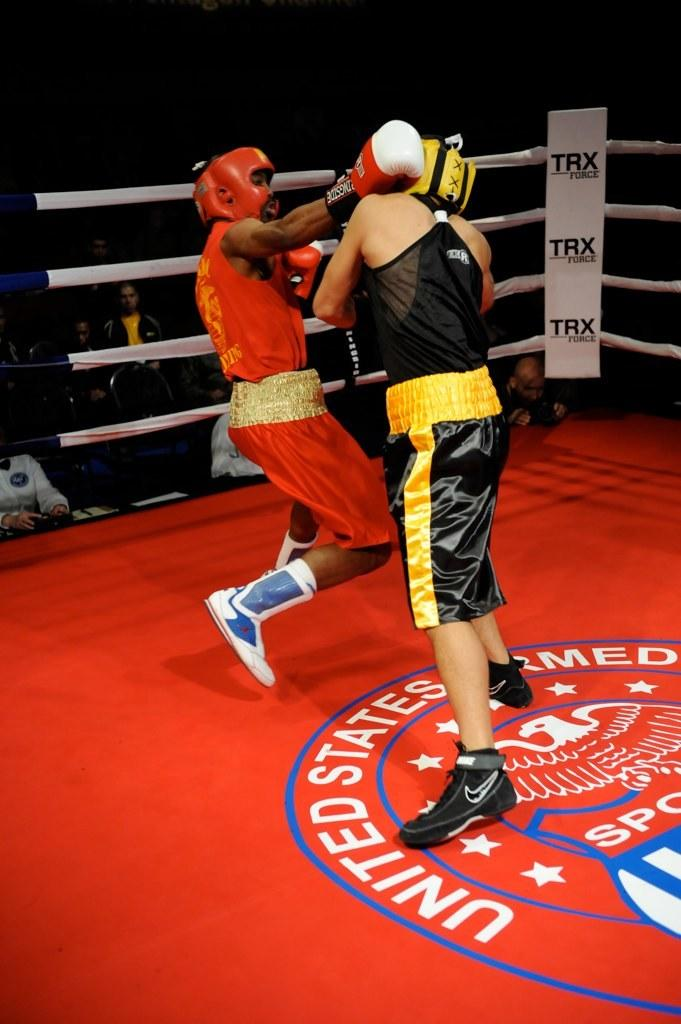<image>
Create a compact narrative representing the image presented. some people fighting in a ring that has United States on it 